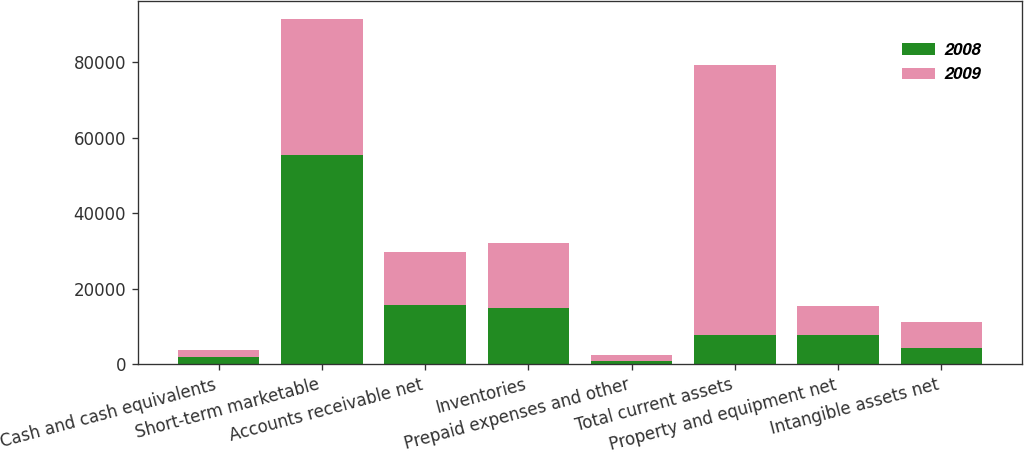Convert chart. <chart><loc_0><loc_0><loc_500><loc_500><stacked_bar_chart><ecel><fcel>Cash and cash equivalents<fcel>Short-term marketable<fcel>Accounts receivable net<fcel>Inventories<fcel>Prepaid expenses and other<fcel>Total current assets<fcel>Property and equipment net<fcel>Intangible assets net<nl><fcel>2008<fcel>1785<fcel>55394<fcel>15724<fcel>14777<fcel>809<fcel>7792<fcel>7792<fcel>4359<nl><fcel>2009<fcel>2042<fcel>36257<fcel>14071<fcel>17428<fcel>1705<fcel>71503<fcel>7551<fcel>6921<nl></chart> 